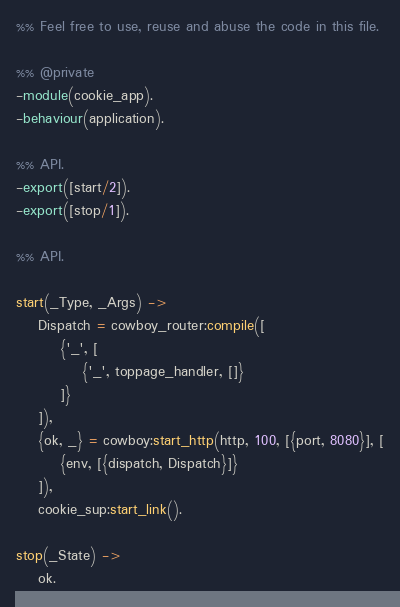<code> <loc_0><loc_0><loc_500><loc_500><_Erlang_>%% Feel free to use, reuse and abuse the code in this file.

%% @private
-module(cookie_app).
-behaviour(application).

%% API.
-export([start/2]).
-export([stop/1]).

%% API.

start(_Type, _Args) ->
	Dispatch = cowboy_router:compile([
		{'_', [
			{'_', toppage_handler, []}
		]}
	]),
	{ok, _} = cowboy:start_http(http, 100, [{port, 8080}], [
		{env, [{dispatch, Dispatch}]}
	]),
	cookie_sup:start_link().

stop(_State) ->
	ok.
</code> 